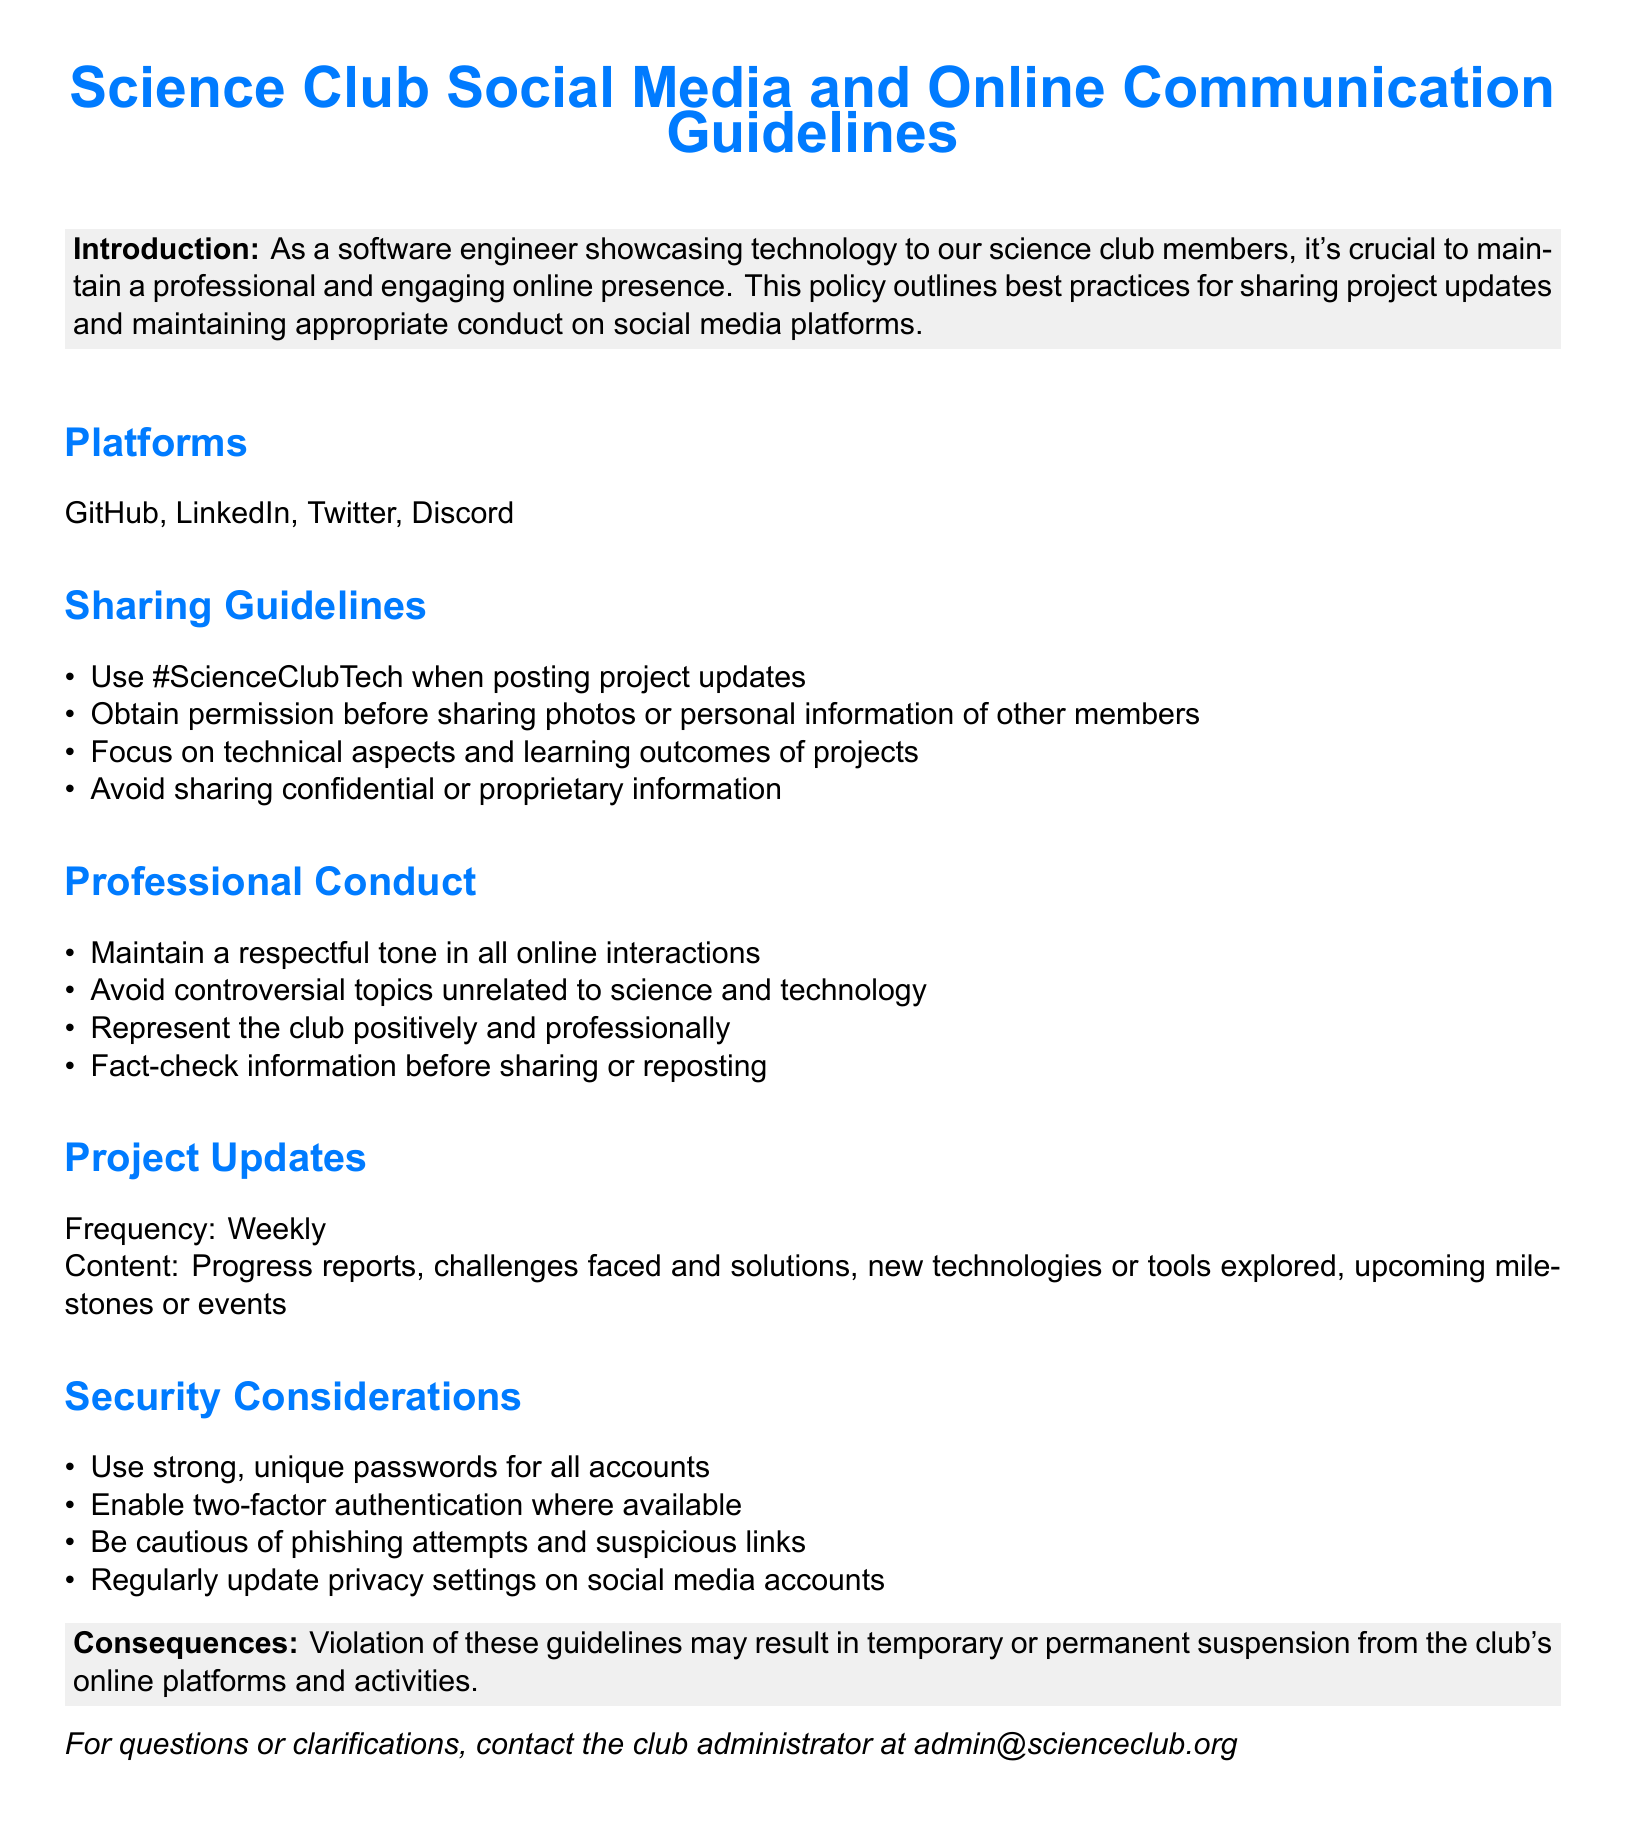what is the main purpose of the document? The document outlines guidelines for maintaining a professional and engaging online presence in the Science Club.
Answer: Social media and online communication policy how often should project updates be shared? The document specifies the frequency for sharing project updates.
Answer: Weekly which platforms are mentioned in the guidelines? The document lists specific platforms where guidelines apply.
Answer: GitHub, LinkedIn, Twitter, Discord what hashtag should be used for posting project updates? The document provides a specific hashtag for sharing project updates.
Answer: #ScienceClubTech what should members avoid sharing according to the guidelines? The document indicates certain types of information that should not be shared.
Answer: Confidential or proprietary information what is the consequence of violating the guidelines? The document outlines potential outcomes of not following the guidelines.
Answer: Suspension from the club's online platforms and activities what tone should be maintained in online interactions? The document emphasizes a particular tone that should be used in communications.
Answer: Respectful tone what action is required before sharing personal information of other members? The document specifies a requirement regarding sharing personal information.
Answer: Obtain permission how should information be treated before sharing or reposting? The document advises on how to handle shared information.
Answer: Fact-check information 